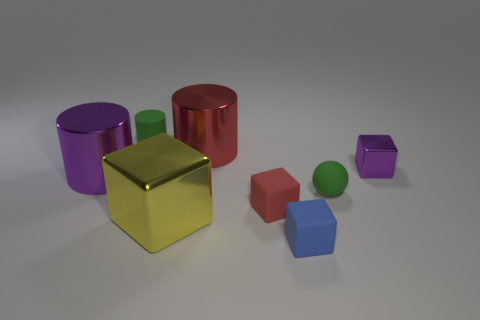Which objects appear to be reflective, and can you describe their positions relative to each other? The purple cylinder, golden cube, and red cylinder display reflective surfaces. The golden cube is between the purple cylinder and the green cuboid, and the red cylinder is next to the green cuboid, on the opposite side of the golden cube. 